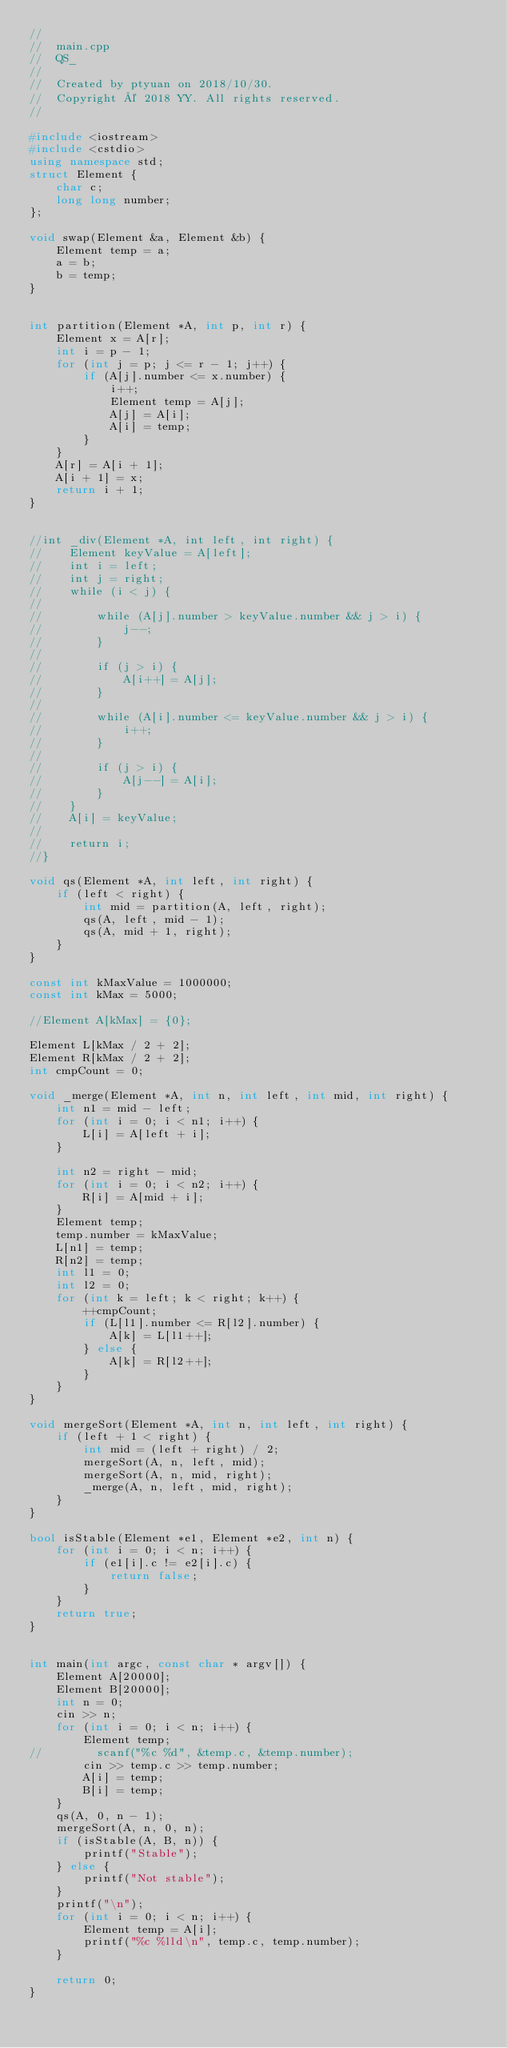Convert code to text. <code><loc_0><loc_0><loc_500><loc_500><_C++_>//
//  main.cpp
//  QS_
//
//  Created by ptyuan on 2018/10/30.
//  Copyright © 2018 YY. All rights reserved.
//

#include <iostream>
#include <cstdio>
using namespace std;
struct Element {
    char c;
    long long number;
};

void swap(Element &a, Element &b) {
    Element temp = a;
    a = b;
    b = temp;
}


int partition(Element *A, int p, int r) {
    Element x = A[r];
    int i = p - 1;
    for (int j = p; j <= r - 1; j++) {
        if (A[j].number <= x.number) {
            i++;
            Element temp = A[j];
            A[j] = A[i];
            A[i] = temp;
        }
    }
    A[r] = A[i + 1];
    A[i + 1] = x;
    return i + 1;
}


//int _div(Element *A, int left, int right) {
//    Element keyValue = A[left];
//    int i = left;
//    int j = right;
//    while (i < j) {
//
//        while (A[j].number > keyValue.number && j > i) {
//            j--;
//        }
//
//        if (j > i) {
//            A[i++] = A[j];
//        }
//
//        while (A[i].number <= keyValue.number && j > i) {
//            i++;
//        }
//
//        if (j > i) {
//            A[j--] = A[i];
//        }
//    }
//    A[i] = keyValue;
//
//    return i;
//}

void qs(Element *A, int left, int right) {
    if (left < right) {
        int mid = partition(A, left, right);
        qs(A, left, mid - 1);
        qs(A, mid + 1, right);
    }
}

const int kMaxValue = 1000000;
const int kMax = 5000;

//Element A[kMax] = {0};

Element L[kMax / 2 + 2];
Element R[kMax / 2 + 2];
int cmpCount = 0;

void _merge(Element *A, int n, int left, int mid, int right) {
    int n1 = mid - left;
    for (int i = 0; i < n1; i++) {
        L[i] = A[left + i];
    }
    
    int n2 = right - mid;
    for (int i = 0; i < n2; i++) {
        R[i] = A[mid + i];
    }
    Element temp;
    temp.number = kMaxValue;
    L[n1] = temp;
    R[n2] = temp;
    int l1 = 0;
    int l2 = 0;
    for (int k = left; k < right; k++) {
        ++cmpCount;
        if (L[l1].number <= R[l2].number) {
            A[k] = L[l1++];
        } else {
            A[k] = R[l2++];
        }
    }
}

void mergeSort(Element *A, int n, int left, int right) {
    if (left + 1 < right) {
        int mid = (left + right) / 2;
        mergeSort(A, n, left, mid);
        mergeSort(A, n, mid, right);
        _merge(A, n, left, mid, right);
    }
}

bool isStable(Element *e1, Element *e2, int n) {
    for (int i = 0; i < n; i++) {
        if (e1[i].c != e2[i].c) {
            return false;
        }
    }
    return true;
}


int main(int argc, const char * argv[]) {
    Element A[20000];
    Element B[20000];
    int n = 0;
    cin >> n;
    for (int i = 0; i < n; i++) {
        Element temp;
//        scanf("%c %d", &temp.c, &temp.number);
        cin >> temp.c >> temp.number;
        A[i] = temp;
        B[i] = temp;
    }
    qs(A, 0, n - 1);
    mergeSort(A, n, 0, n);
    if (isStable(A, B, n)) {
        printf("Stable");
    } else {
        printf("Not stable");
    }
    printf("\n");
    for (int i = 0; i < n; i++) {
        Element temp = A[i];
        printf("%c %lld\n", temp.c, temp.number);
    }
    
    return 0;
}


</code> 